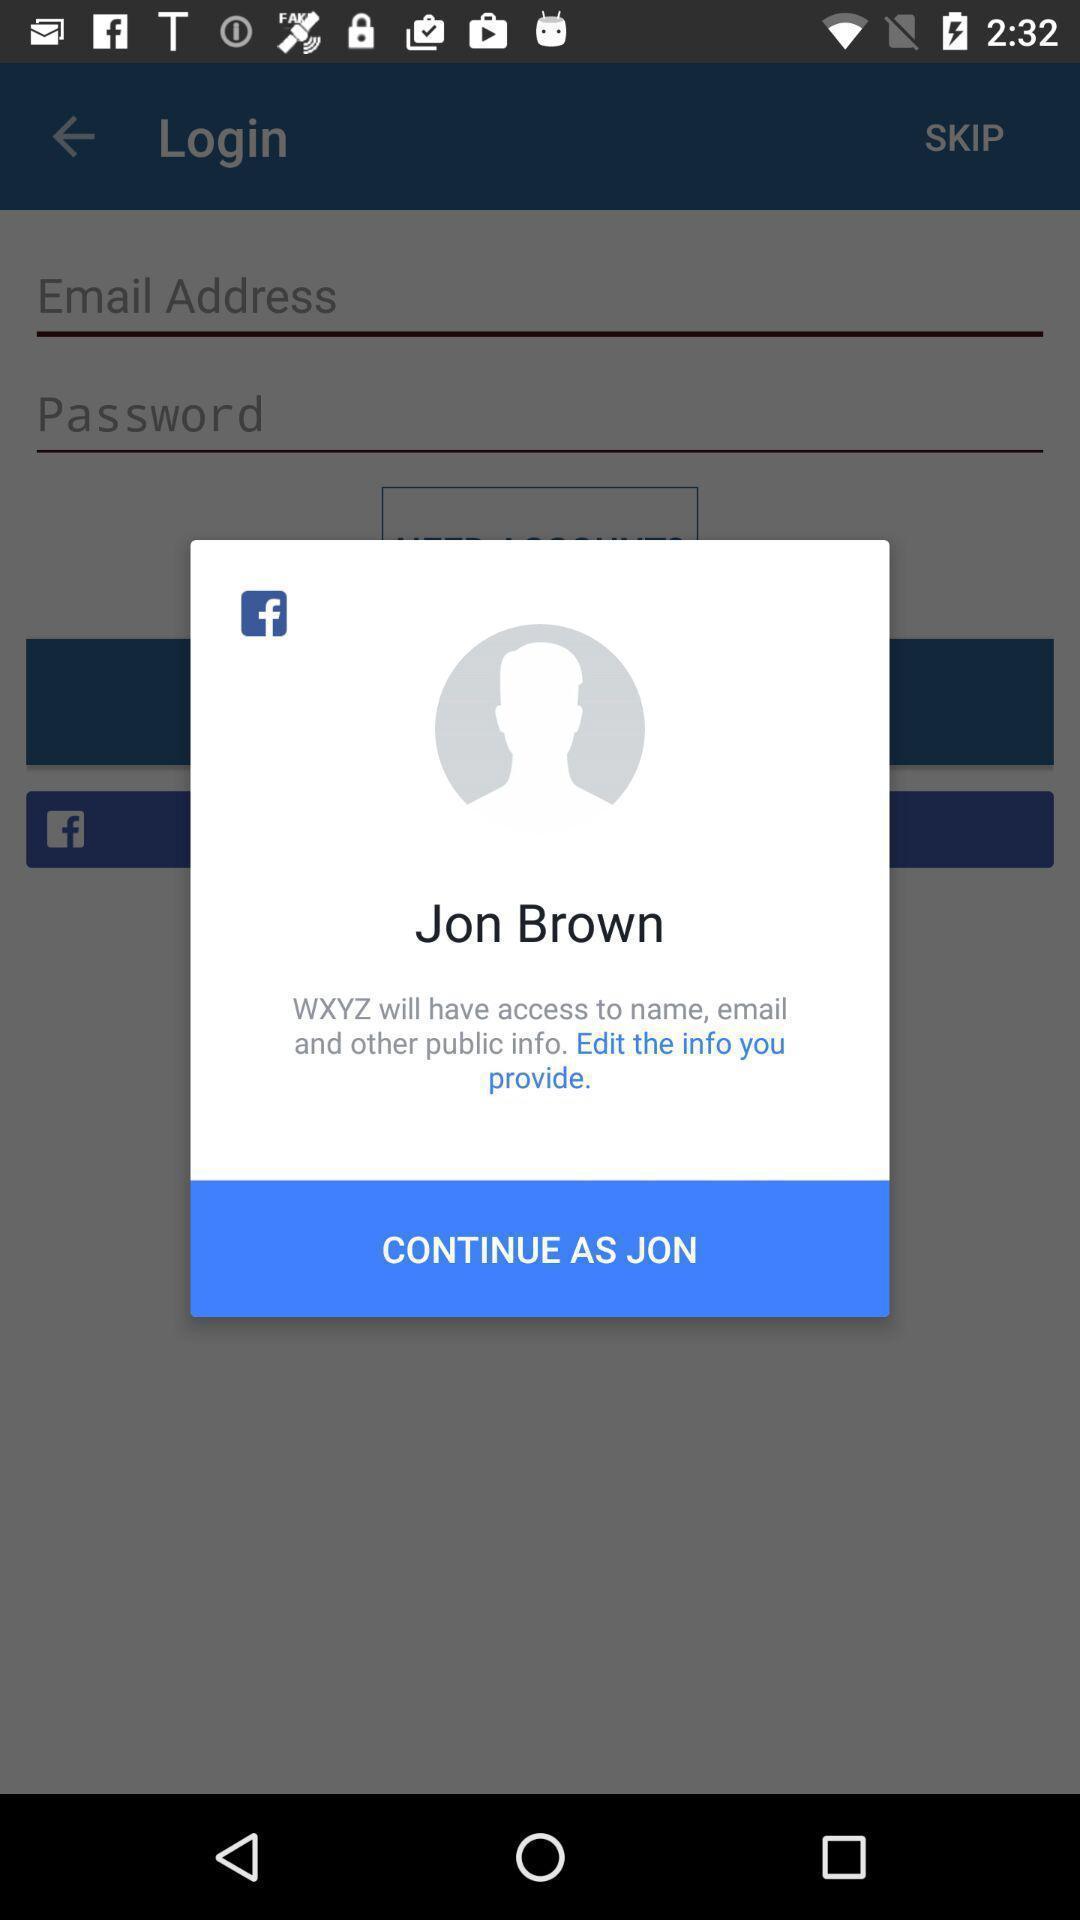Describe the content in this image. Pop up message of a social app. 